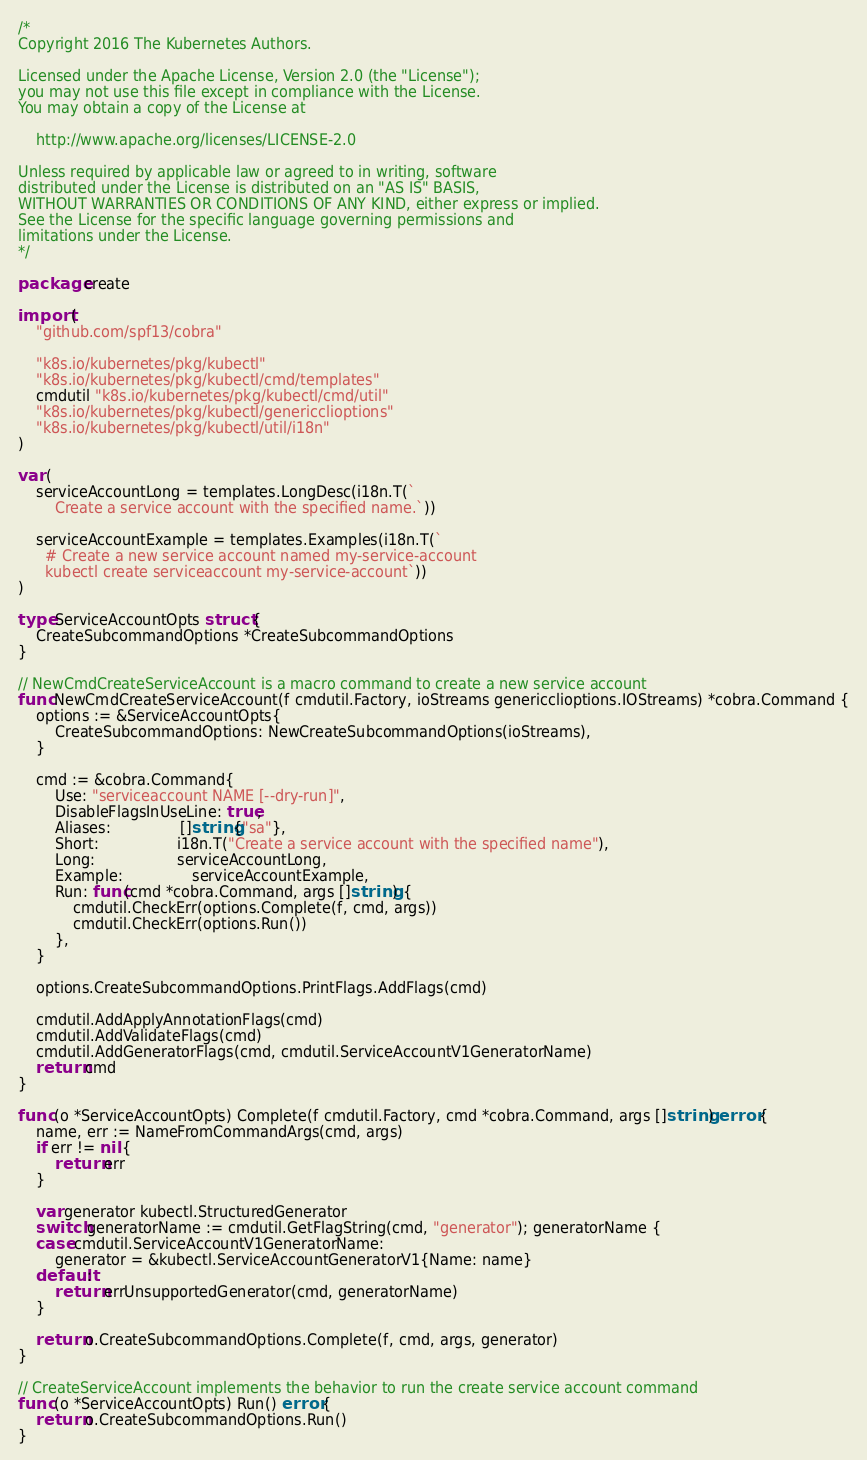Convert code to text. <code><loc_0><loc_0><loc_500><loc_500><_Go_>/*
Copyright 2016 The Kubernetes Authors.

Licensed under the Apache License, Version 2.0 (the "License");
you may not use this file except in compliance with the License.
You may obtain a copy of the License at

    http://www.apache.org/licenses/LICENSE-2.0

Unless required by applicable law or agreed to in writing, software
distributed under the License is distributed on an "AS IS" BASIS,
WITHOUT WARRANTIES OR CONDITIONS OF ANY KIND, either express or implied.
See the License for the specific language governing permissions and
limitations under the License.
*/

package create

import (
	"github.com/spf13/cobra"

	"k8s.io/kubernetes/pkg/kubectl"
	"k8s.io/kubernetes/pkg/kubectl/cmd/templates"
	cmdutil "k8s.io/kubernetes/pkg/kubectl/cmd/util"
	"k8s.io/kubernetes/pkg/kubectl/genericclioptions"
	"k8s.io/kubernetes/pkg/kubectl/util/i18n"
)

var (
	serviceAccountLong = templates.LongDesc(i18n.T(`
		Create a service account with the specified name.`))

	serviceAccountExample = templates.Examples(i18n.T(`
	  # Create a new service account named my-service-account
	  kubectl create serviceaccount my-service-account`))
)

type ServiceAccountOpts struct {
	CreateSubcommandOptions *CreateSubcommandOptions
}

// NewCmdCreateServiceAccount is a macro command to create a new service account
func NewCmdCreateServiceAccount(f cmdutil.Factory, ioStreams genericclioptions.IOStreams) *cobra.Command {
	options := &ServiceAccountOpts{
		CreateSubcommandOptions: NewCreateSubcommandOptions(ioStreams),
	}

	cmd := &cobra.Command{
		Use: "serviceaccount NAME [--dry-run]",
		DisableFlagsInUseLine: true,
		Aliases:               []string{"sa"},
		Short:                 i18n.T("Create a service account with the specified name"),
		Long:                  serviceAccountLong,
		Example:               serviceAccountExample,
		Run: func(cmd *cobra.Command, args []string) {
			cmdutil.CheckErr(options.Complete(f, cmd, args))
			cmdutil.CheckErr(options.Run())
		},
	}

	options.CreateSubcommandOptions.PrintFlags.AddFlags(cmd)

	cmdutil.AddApplyAnnotationFlags(cmd)
	cmdutil.AddValidateFlags(cmd)
	cmdutil.AddGeneratorFlags(cmd, cmdutil.ServiceAccountV1GeneratorName)
	return cmd
}

func (o *ServiceAccountOpts) Complete(f cmdutil.Factory, cmd *cobra.Command, args []string) error {
	name, err := NameFromCommandArgs(cmd, args)
	if err != nil {
		return err
	}

	var generator kubectl.StructuredGenerator
	switch generatorName := cmdutil.GetFlagString(cmd, "generator"); generatorName {
	case cmdutil.ServiceAccountV1GeneratorName:
		generator = &kubectl.ServiceAccountGeneratorV1{Name: name}
	default:
		return errUnsupportedGenerator(cmd, generatorName)
	}

	return o.CreateSubcommandOptions.Complete(f, cmd, args, generator)
}

// CreateServiceAccount implements the behavior to run the create service account command
func (o *ServiceAccountOpts) Run() error {
	return o.CreateSubcommandOptions.Run()
}
</code> 